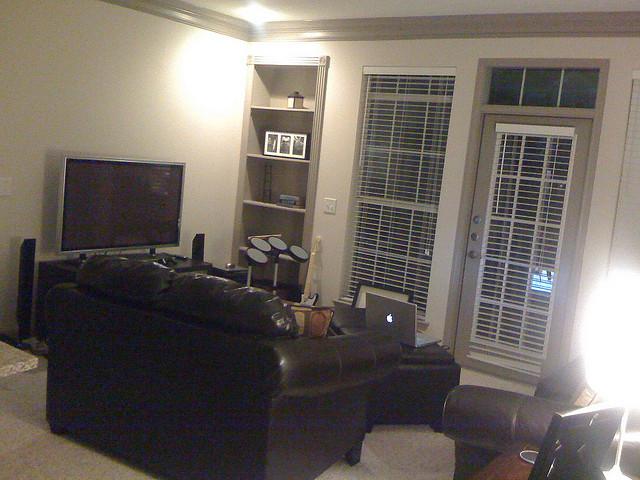What color is the couch?
Concise answer only. Brown. What color is the carpet?
Give a very brief answer. Beige. What brand of laptop is on the bench?
Write a very short answer. Apple. Where is a musical instrument?
Answer briefly. By bookcase. What is causing that glare?
Quick response, please. Lamp. What kind of room is this?
Write a very short answer. Living room. Is the door open?
Give a very brief answer. No. Are the blinds closed?
Be succinct. No. Is this a recent photo?
Be succinct. Yes. Are there any pictures on the wall?
Quick response, please. No. Is it daytime or is it nighttime?
Answer briefly. Nighttime. 